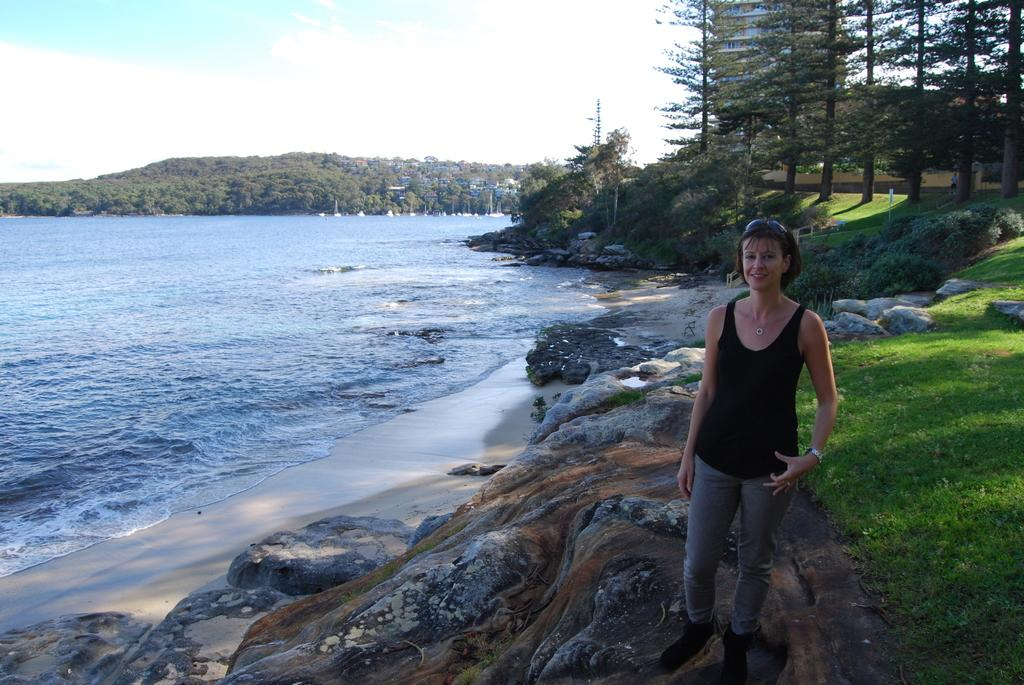What natural feature is the main subject of the image? There is a river in the image. What is the woman in the image doing? A woman is standing on the bank of the river. What can be seen in the background of the image? There are trees, mountains, and the sky visible in the background of the image. What type of straw is the woman using to build a plot in the image? There is no straw or plot-building activity present in the image. 